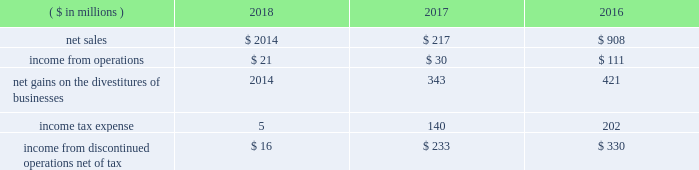2018 ppg annual report and form 10-k 59 other acquisitions in 2018 , 2017 , and 2016 , the company completed several smaller business acquisitions .
The total consideration paid for these acquisitions , net of cash acquired , debt assumed and other post closing adjustments , was $ 108 million , $ 74 million and $ 43 million , respectively .
In january 2018 , ppg acquired procoatings , a leading architectural paint and coatings wholesaler located in the netherlands .
Procoatings , established in 2001 , distributes a large portfolio of well-known professional paint brands through its network of 23 multi-brand stores .
The company employs nearly 100 people .
The results of this business since the date of acquisition have been reported within the architectural coatings americas and asia pacific business within the performance coatings reportable segment .
In january 2017 , ppg acquired certain assets of automotive refinish coatings company futian xinshi ( 201cfutian 201d ) , based in the guangdong province of china .
Futian distributes its products in china through a network of more than 200 distributors .
In january 2017 , ppg completed the acquisition of deutek s.a. , a leading romanian paint and architectural coatings manufacturer , from the emerging europe accession fund .
Deutek , established in 1993 , manufactures and markets a large portfolio of well-known professional and consumer paint brands , including oskar and danke! .
The company 2019s products are sold in more than 120 do-it-yourself stores and 3500 independent retail outlets in romania .
Divestitures glass segment in 2017 , ppg completed a multi-year strategic shift in the company's business portfolio , resulting in the exit of all glass operations which consisted of the global fiber glass business , ppg's ownership interest in two asian fiber glass joint ventures and the flat glass business .
Accordingly , the results of operations , including the gains on the divestitures , and cash flows have been recast as discontinued operations for all periods presented .
Ppg now has two reportable business segments .
The net sales and income from discontinued operations related to the former glass segment for the three years ended december 31 , 2018 , 2017 , and 2016 were as follows: .
During 2018 , ppg released $ 13 million of previously recorded accruals and contingencies established in conjunction with the divestitures of businesses within the former glass segment as a result of completed actions , new information and updated estimates .
Also during 2018 , ppg made a final payment of $ 20 million to vitro s.a.b .
De c.v related to the transfer of certain pension obligations upon the sale of the former flat glass business .
North american fiber glass business on september 1 , 2017 , ppg completed the sale of its north american fiber glass business to nippon electric glass co .
Ltd .
( 201cneg 201d ) .
Cash proceeds from the sale were $ 541 million , resulting in a pre-tax gain of $ 343 million , net of certain accruals and contingencies established in conjunction with the divestiture .
Ppg 2019s fiber glass operations included manufacturing facilities in chester , south carolina , and lexington and shelby , north carolina ; and administrative and research-and-development operations in shelby and in harmar , pennsylvania , near pittsburgh .
The business , which employed more than 1000 people and had net sales of approximately $ 350 million in 2016 , supplies the transportation , energy , infrastructure and consumer markets .
Flat glass business in october 2016 , ppg completed the sale of its flat glass manufacturing and glass coatings operations to vitro s.a.b .
De c.v .
Ppg received approximately $ 740 million in cash proceeds and recorded a pre-tax gain of $ 421 million on the sale .
Under the terms of the agreement , ppg divested its entire flat glass manufacturing and glass coatings operations , including production sites located in fresno , california ; salem , oregon ; carlisle , pennsylvania ; and wichita falls , texas ; four distribution/fabrication facilities located across canada ; and a research-and-development center located in harmar , pennsylvania .
Ppg 2019s flat glass business included approximately 1200 employees .
The business manufactures glass that is fabricated into products used primarily in commercial and residential construction .
Notes to the consolidated financial statements .
What was the change in net sales for the discontinued operations related to the former glass segment from 2016 to 2017 in millions? 
Computations: (217 - 908)
Answer: -691.0. 